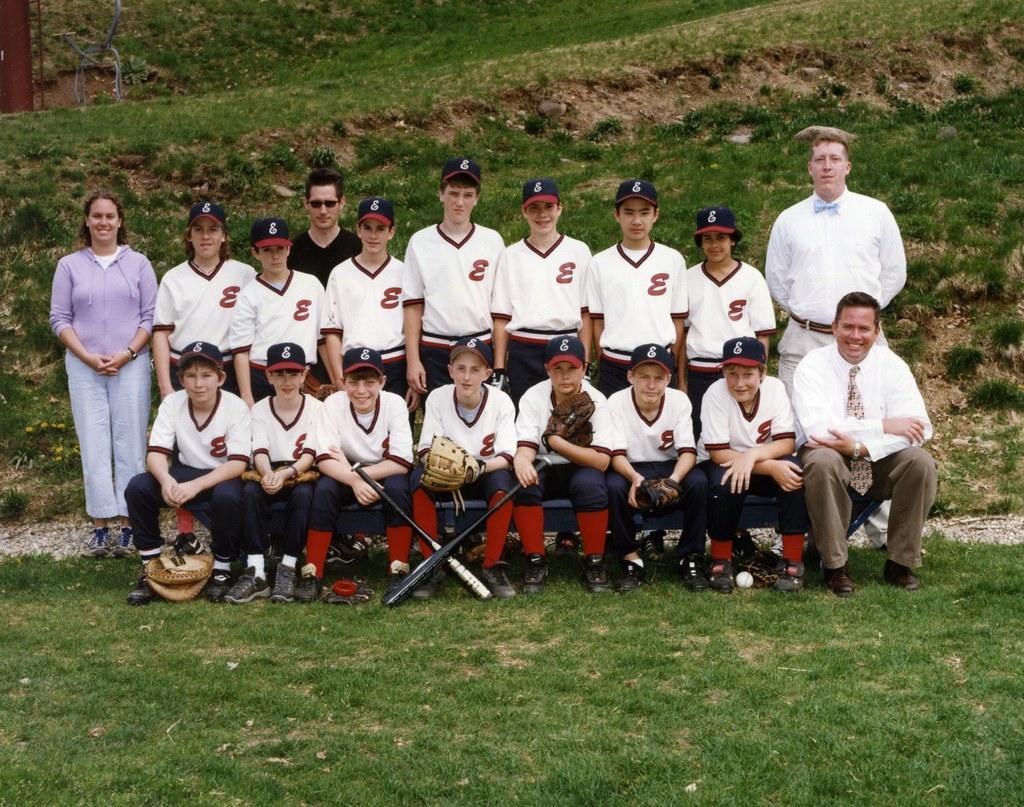Describe this image in one or two sentences. This picture describes about group of people, few are seated, few are standing and few people wore caps, in front of them we can see bats, ball and gloves, and also we can see grass. 